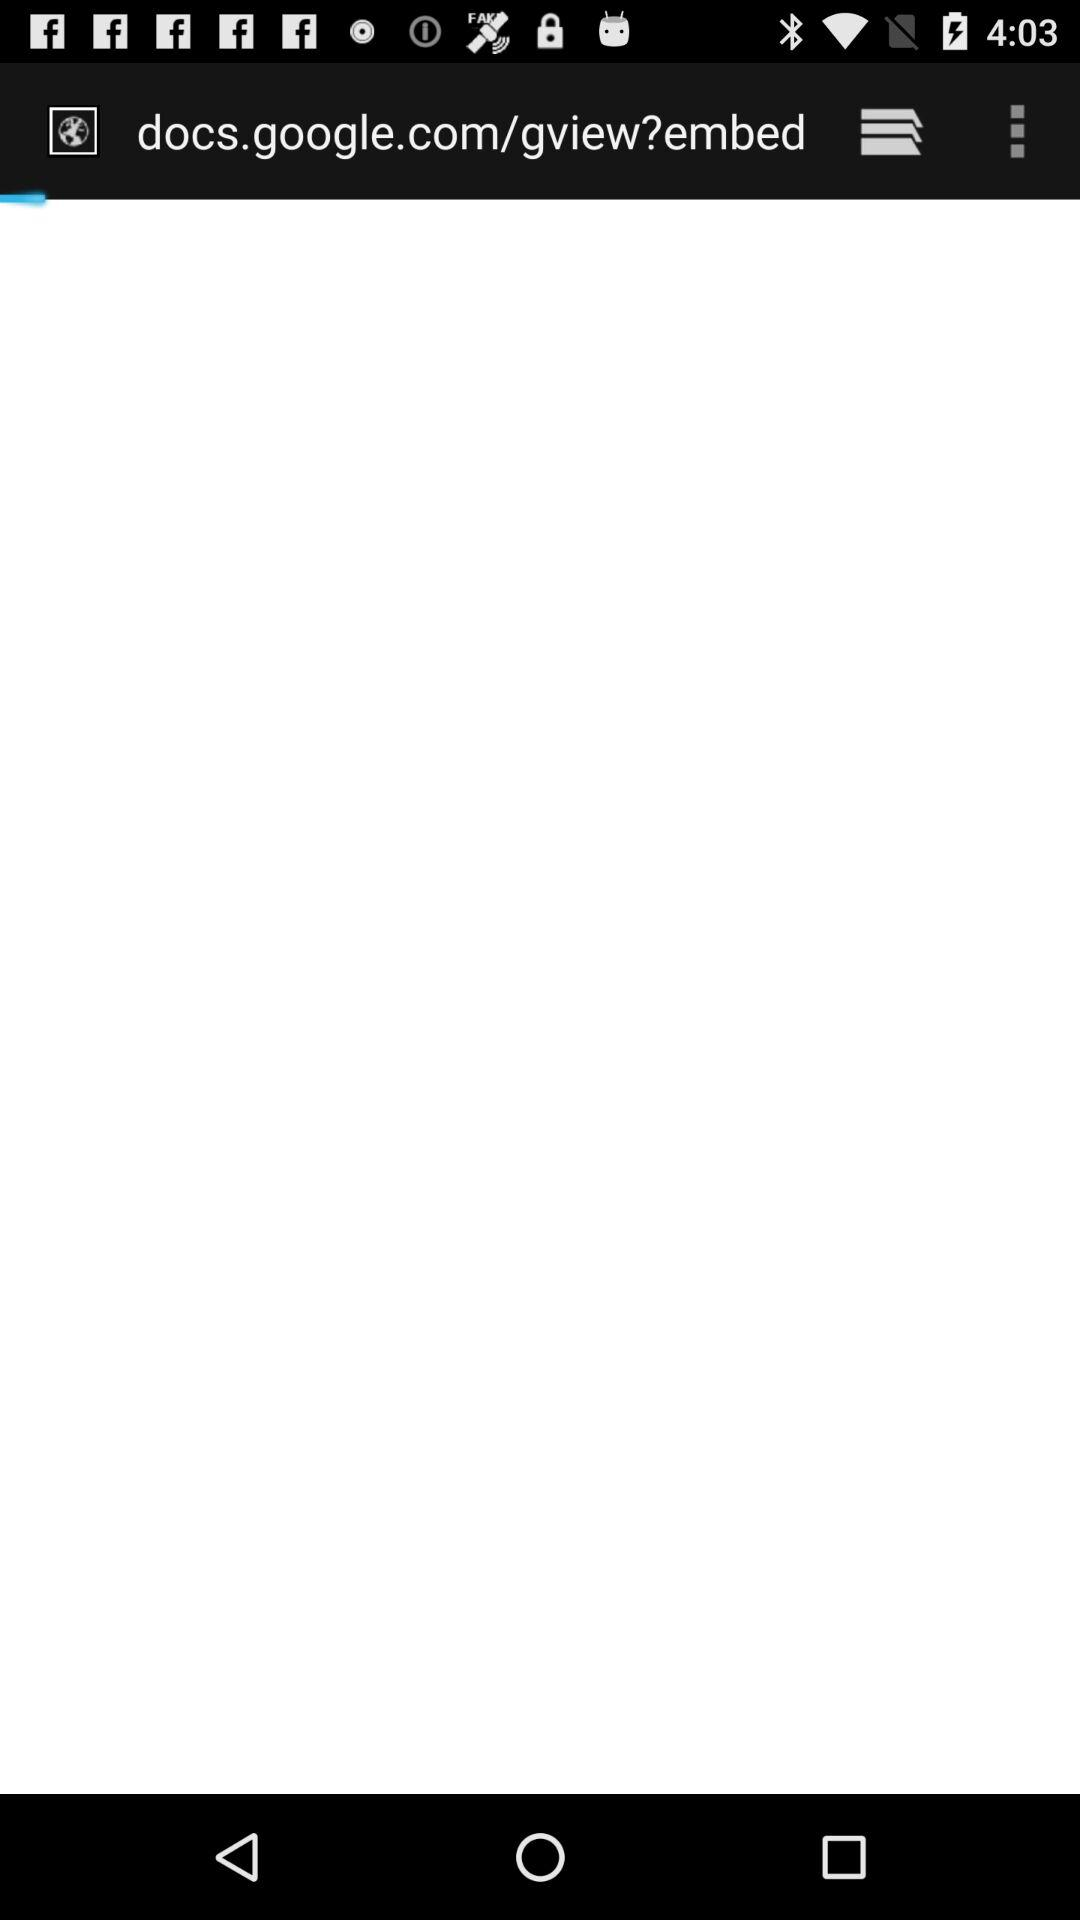What application is asking for permission? The application that is asking for permission is "Free Caddie". 